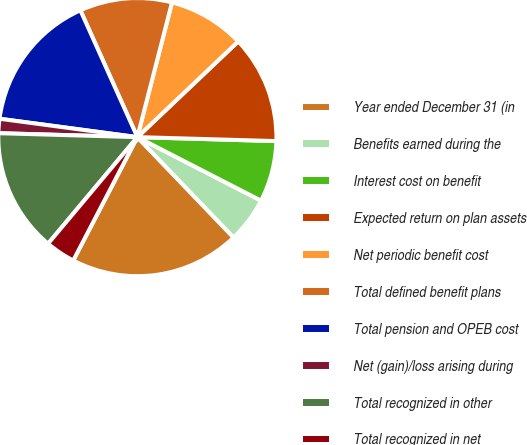<chart> <loc_0><loc_0><loc_500><loc_500><pie_chart><fcel>Year ended December 31 (in<fcel>Benefits earned during the<fcel>Interest cost on benefit<fcel>Expected return on plan assets<fcel>Net periodic benefit cost<fcel>Total defined benefit plans<fcel>Total pension and OPEB cost<fcel>Net (gain)/loss arising during<fcel>Total recognized in other<fcel>Total recognized in net<nl><fcel>19.8%<fcel>5.28%<fcel>7.1%<fcel>12.54%<fcel>8.91%<fcel>10.73%<fcel>16.17%<fcel>1.66%<fcel>14.35%<fcel>3.47%<nl></chart> 